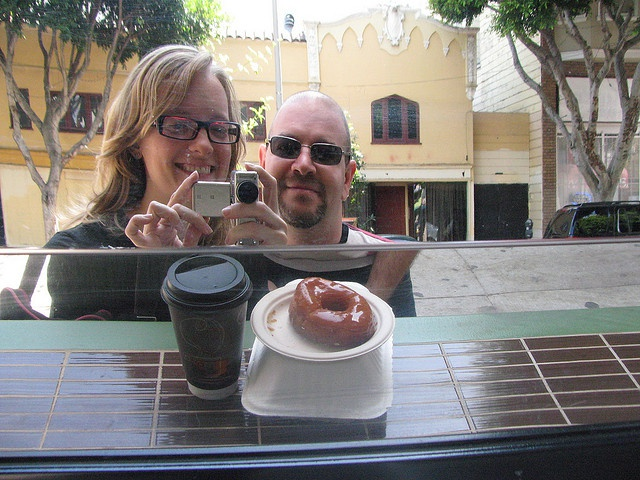Describe the objects in this image and their specific colors. I can see people in black, gray, and maroon tones, people in black, gray, and lightgray tones, cup in black and gray tones, donut in black, brown, darkgray, and maroon tones, and car in black, gray, and darkgreen tones in this image. 